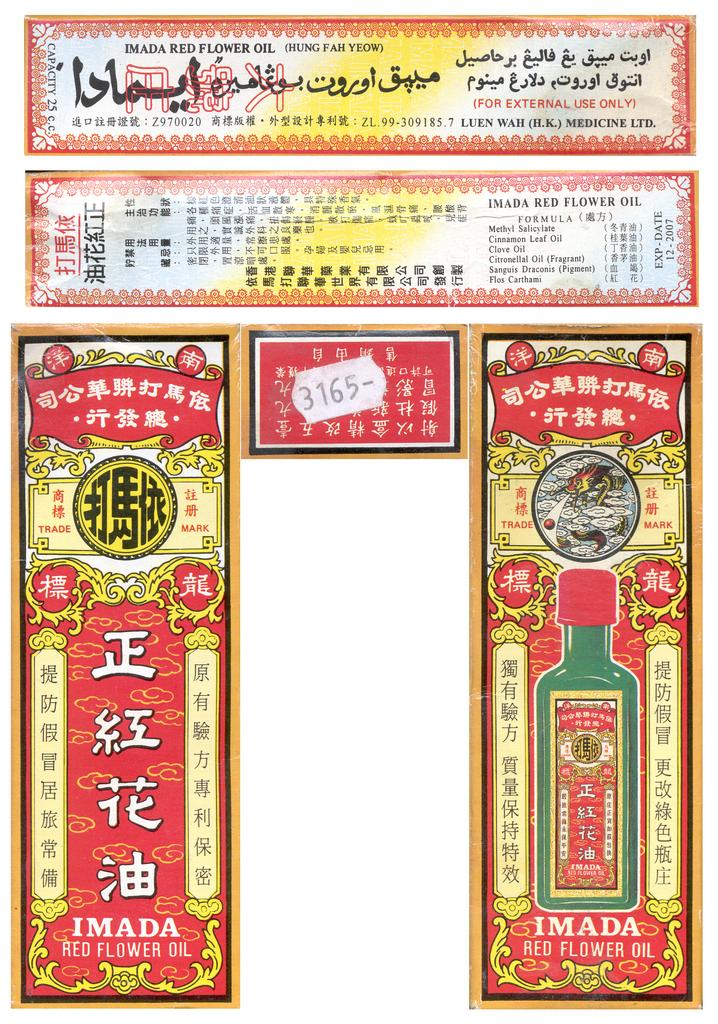<image>
Describe the image concisely. Chinese medicine posters for Imada Red Flower Oil. 